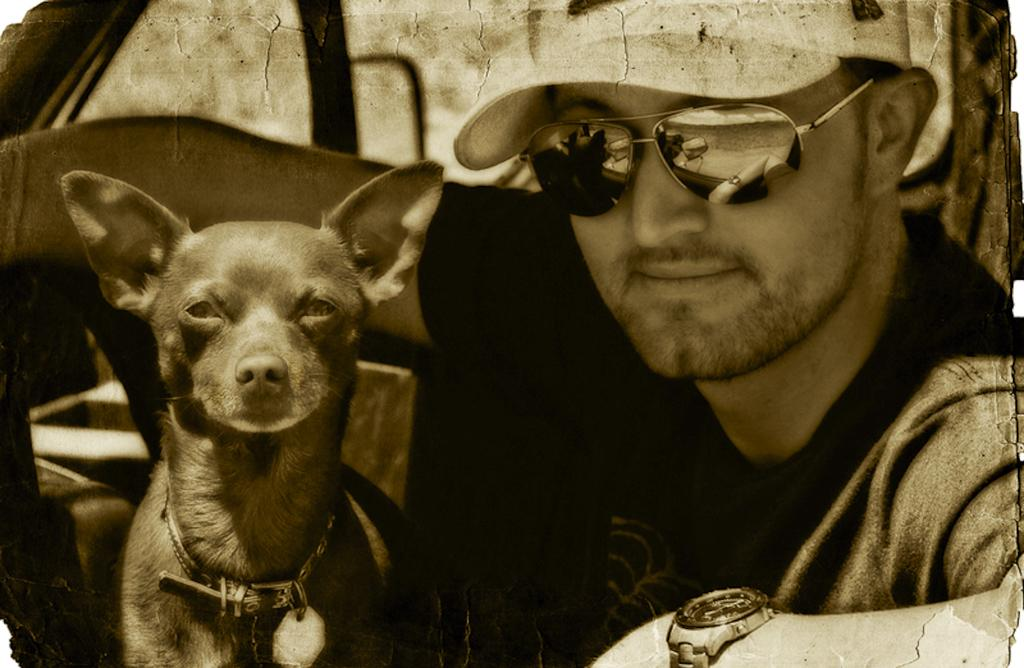What is the person in the image wearing on their face? The person is wearing goggles. What type of headwear is the person wearing in the image? The person is wearing a cap. What accessory is the person wearing on their wrist? The person is wearing a watch. What is the person doing in the image? The person is sitting in a vehicle. What animal is present in the image? There is a dog in the image. How is the dog being restrained in the image? The dog has a chain around its neck. What type of powder is being used to clean the dog's teeth in the image? There is no powder or teeth cleaning activity depicted in the image; the dog has a chain around its neck. 